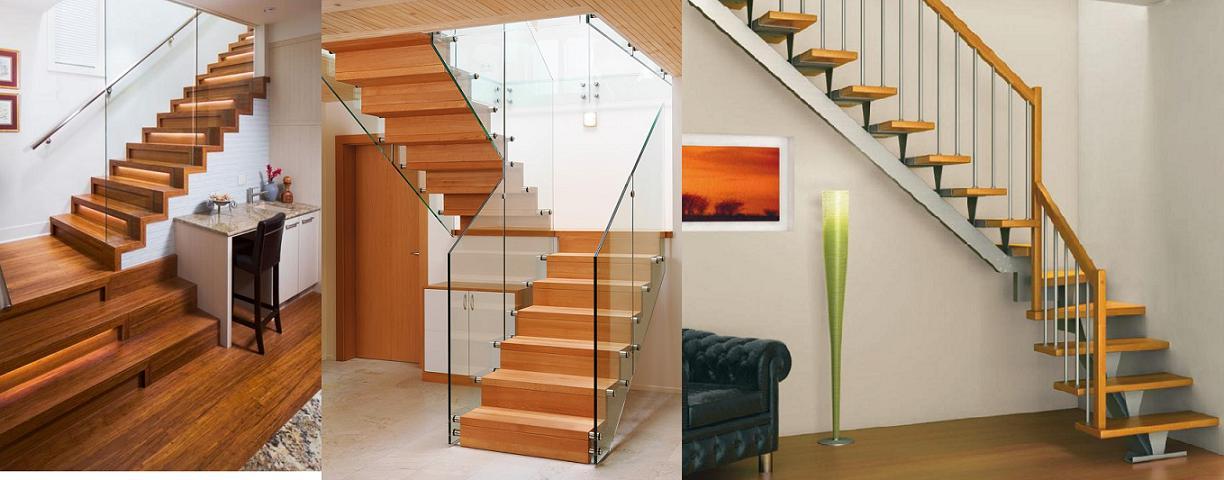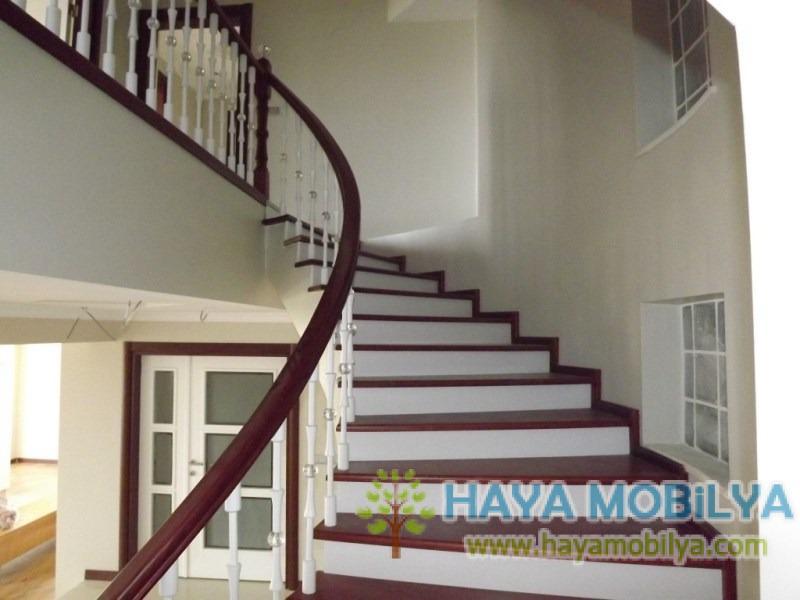The first image is the image on the left, the second image is the image on the right. For the images displayed, is the sentence "The stairs in the image on the right curve near a large open window." factually correct? Answer yes or no. No. The first image is the image on the left, the second image is the image on the right. Considering the images on both sides, is "The right image features a staircase with a curved wood rail, and the left image features a staircase with a right-angle turn." valid? Answer yes or no. Yes. 